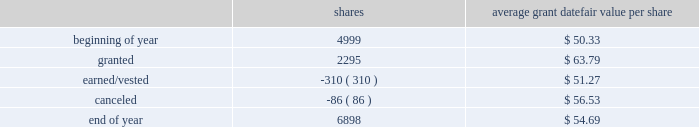2018 emerson annual report | 51 as of september 30 , 2018 , 1874750 shares awarded primarily in 2016 were outstanding , contingent on the company achieving its performance objectives through 2018 .
The objectives for these shares were met at the 97 percent level at the end of 2018 and 1818508 shares will be distributed in early 2019 .
Additionally , the rights to receive a maximum of 2261700 and 2375313 common shares were awarded in 2018 and 2017 , respectively , under the new performance shares program , and are outstanding and contingent upon the company achieving its performance objectives through 2020 and 2019 , respectively .
Incentive shares plans also include restricted stock awards which involve distribution of common stock to key management employees subject to cliff vesting at the end of service periods ranging from three to ten years .
The fair value of restricted stock awards is determined based on the average of the high and low market prices of the company 2019s common stock on the date of grant , with compensation expense recognized ratably over the applicable service period .
In 2018 , 310000 shares of restricted stock vested as a result of participants fulfilling the applicable service requirements .
Consequently , 167837 shares were issued while 142163 shares were withheld for income taxes in accordance with minimum withholding requirements .
As of september 30 , 2018 , there were 1276200 shares of unvested restricted stock outstanding .
The total fair value of shares distributed under incentive shares plans was $ 20 , $ 245 and $ 11 , respectively , in 2018 , 2017 and 2016 , of which $ 9 , $ 101 and $ 4 was paid in cash , primarily for tax withholding .
As of september 30 , 2018 , 10.3 million shares remained available for award under incentive shares plans .
Changes in shares outstanding but not yet earned under incentive shares plans during the year ended september 30 , 2018 follow ( shares in thousands ; assumes 100 percent payout of unvested awards ) : average grant date shares fair value per share .
Total compensation expense for stock options and incentive shares was $ 216 , $ 115 and $ 159 for 2018 , 2017 and 2016 , respectively , of which $ 5 and $ 14 was included in discontinued operations for 2017 and 2016 , respectively .
The increase in expense for 2018 reflects an increase in the company 2019s stock price and progress toward achieving its performance objectives .
The decrease in expense for 2017 reflects the impact of changes in the stock price .
Income tax benefits recognized in the income statement for these compensation arrangements during 2018 , 2017 and 2016 were $ 42 , $ 33 and $ 45 , respectively .
As of september 30 , 2018 , total unrecognized compensation expense related to unvested shares awarded under these plans was $ 182 , which is expected to be recognized over a weighted-average period of 1.1 years .
In addition to the employee stock option and incentive shares plans , in 2018 the company awarded 12228 shares of restricted stock and 2038 restricted stock units under the restricted stock plan for non-management directors .
As of september 30 , 2018 , 159965 shares were available for issuance under this plan .
( 16 ) common and preferred stock at september 30 , 2018 , 37.0 million shares of common stock were reserved for issuance under the company 2019s stock-based compensation plans .
During 2018 , 15.1 million common shares were purchased and 2.6 million treasury shares were reissued .
In 2017 , 6.6 million common shares were purchased and 5.5 million treasury shares were reissued .
At september 30 , 2018 and 2017 , the company had 5.4 million shares of $ 2.50 par value preferred stock authorized , with none issued. .
What was the total grant datefair value , in dollars , at the beginning of the year? 
Rationale: average grant datefair value per share*number of shares = total grant datefair value
Computations: (50.33 * 4999)
Answer: 251599.67. 